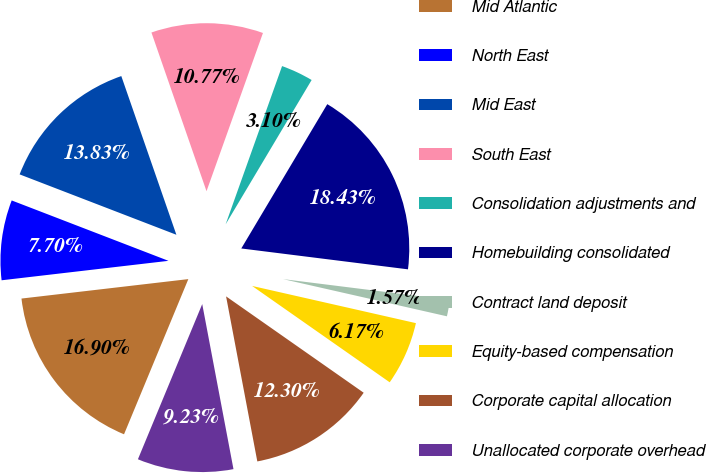<chart> <loc_0><loc_0><loc_500><loc_500><pie_chart><fcel>Mid Atlantic<fcel>North East<fcel>Mid East<fcel>South East<fcel>Consolidation adjustments and<fcel>Homebuilding consolidated<fcel>Contract land deposit<fcel>Equity-based compensation<fcel>Corporate capital allocation<fcel>Unallocated corporate overhead<nl><fcel>16.9%<fcel>7.7%<fcel>13.83%<fcel>10.77%<fcel>3.1%<fcel>18.43%<fcel>1.57%<fcel>6.17%<fcel>12.3%<fcel>9.23%<nl></chart> 